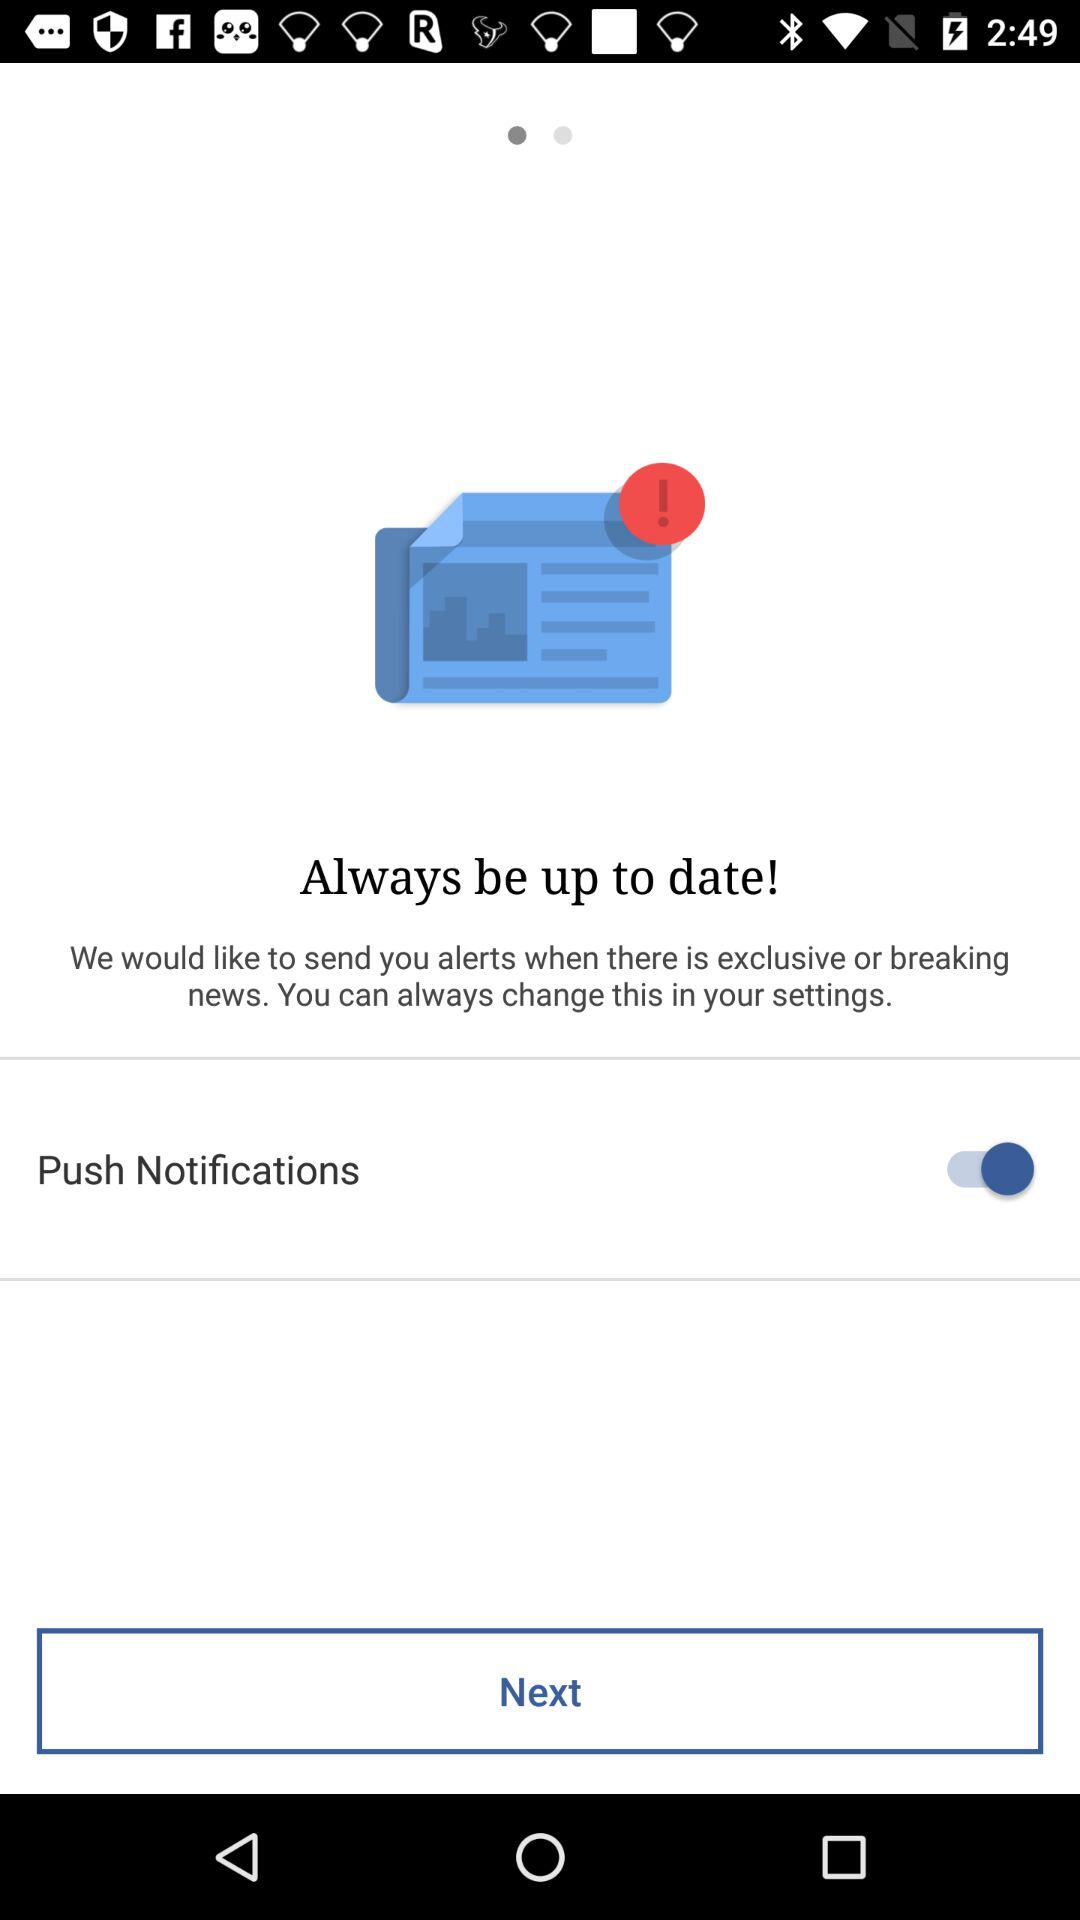What's the status of "Push Notifications"? The status is "on". 